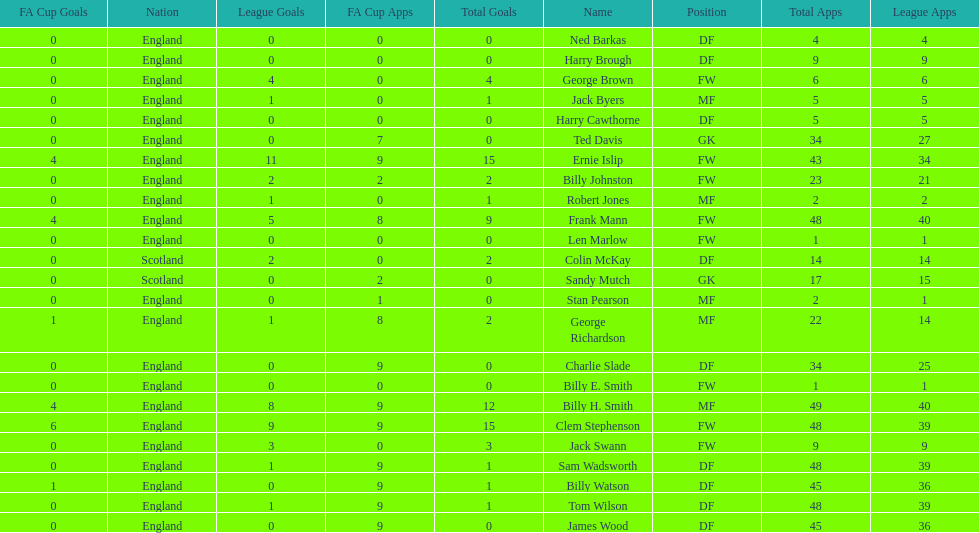The least number of total appearances 1. 